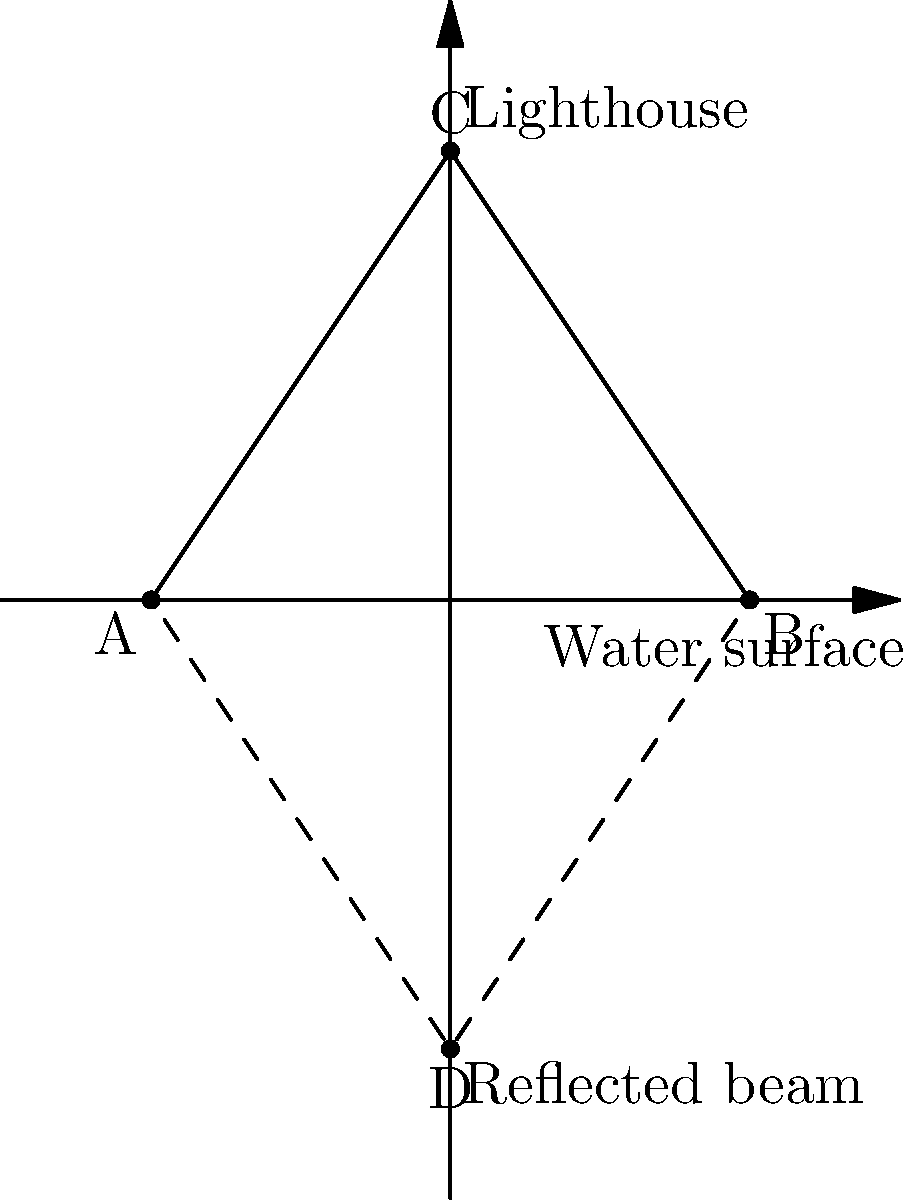A lighthouse on a cliff projects a beam of light onto the calm sea surface, creating a reflection. If the lighthouse is located at point C(2,3) and its reflection on the water surface creates point D(2,-3), determine the equation of the line of reflection (water surface) using transformational geometry concepts. To solve this problem, we'll use the concept of reflection in transformational geometry:

1) In a reflection, the line of reflection is the perpendicular bisector of the line segment connecting a point and its image.

2) The line segment CD connects the lighthouse (C) and its reflection (D).

3) The midpoint of CD will be a point on the line of reflection (water surface). 
   Midpoint = $(\frac{x_1+x_2}{2}, \frac{y_1+y_2}{2})$ = $(2, \frac{3+(-3)}{2})$ = $(2,0)$

4) The line of reflection is perpendicular to CD. The slope of CD is:
   $m_{CD} = \frac{y_D - y_C}{x_D - x_C} = \frac{-3 - 3}{2 - 2} = undefined$

5) Since the slope of CD is undefined, CD is vertical. Therefore, the line of reflection must be horizontal.

6) A horizontal line has a slope of 0 and its equation is of the form $y = k$, where $k$ is the y-intercept.

7) We found that the midpoint (2,0) is on this line, so $k = 0$.

Therefore, the equation of the line of reflection (water surface) is $y = 0$.
Answer: $y = 0$ 